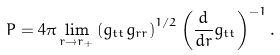<formula> <loc_0><loc_0><loc_500><loc_500>P = 4 \pi \lim _ { r \rightarrow r _ { + } } \left ( g _ { t t } g _ { r r } \right ) ^ { 1 / 2 } \left ( \frac { d } { d r } g _ { t t } \right ) ^ { - 1 } .</formula> 